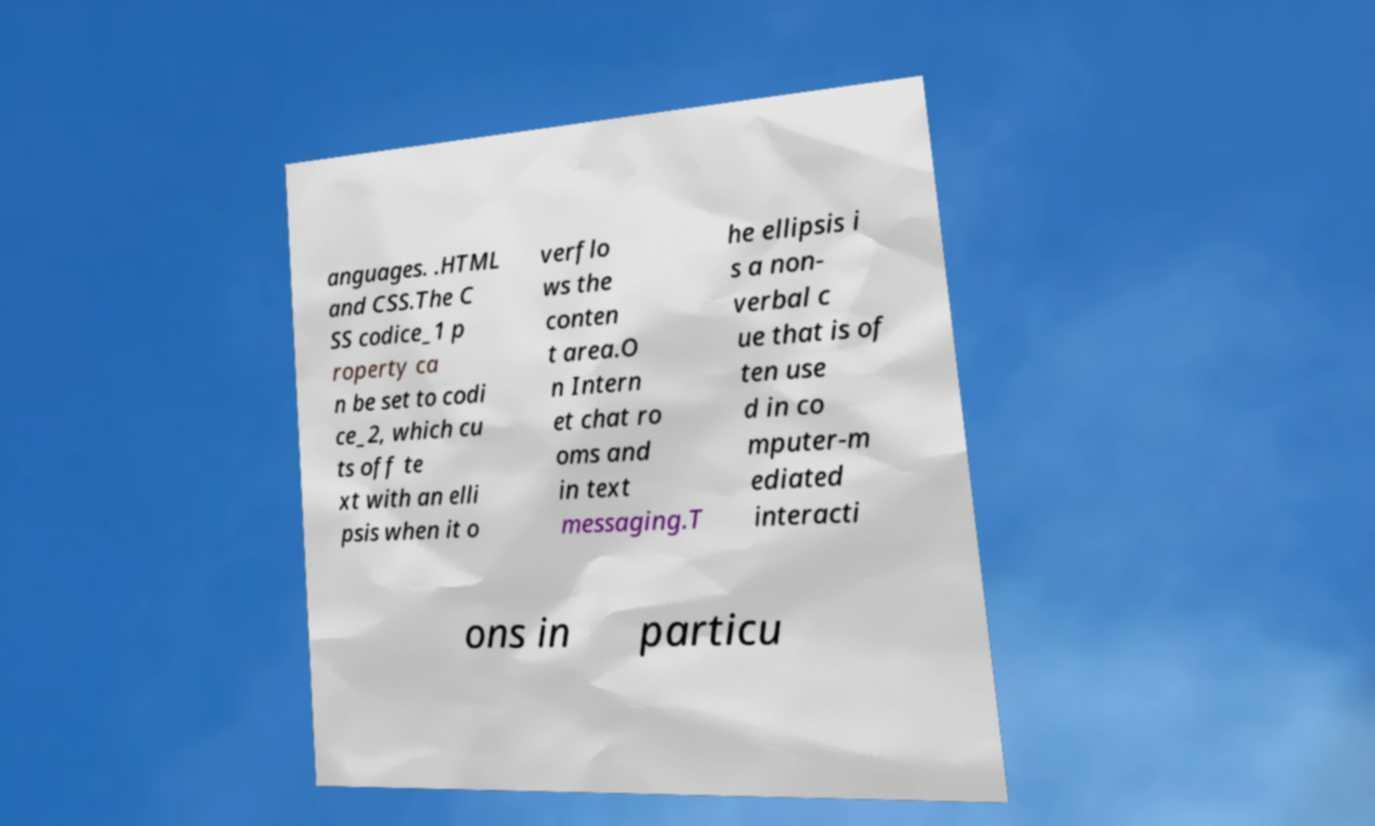Can you accurately transcribe the text from the provided image for me? anguages. .HTML and CSS.The C SS codice_1 p roperty ca n be set to codi ce_2, which cu ts off te xt with an elli psis when it o verflo ws the conten t area.O n Intern et chat ro oms and in text messaging.T he ellipsis i s a non- verbal c ue that is of ten use d in co mputer-m ediated interacti ons in particu 